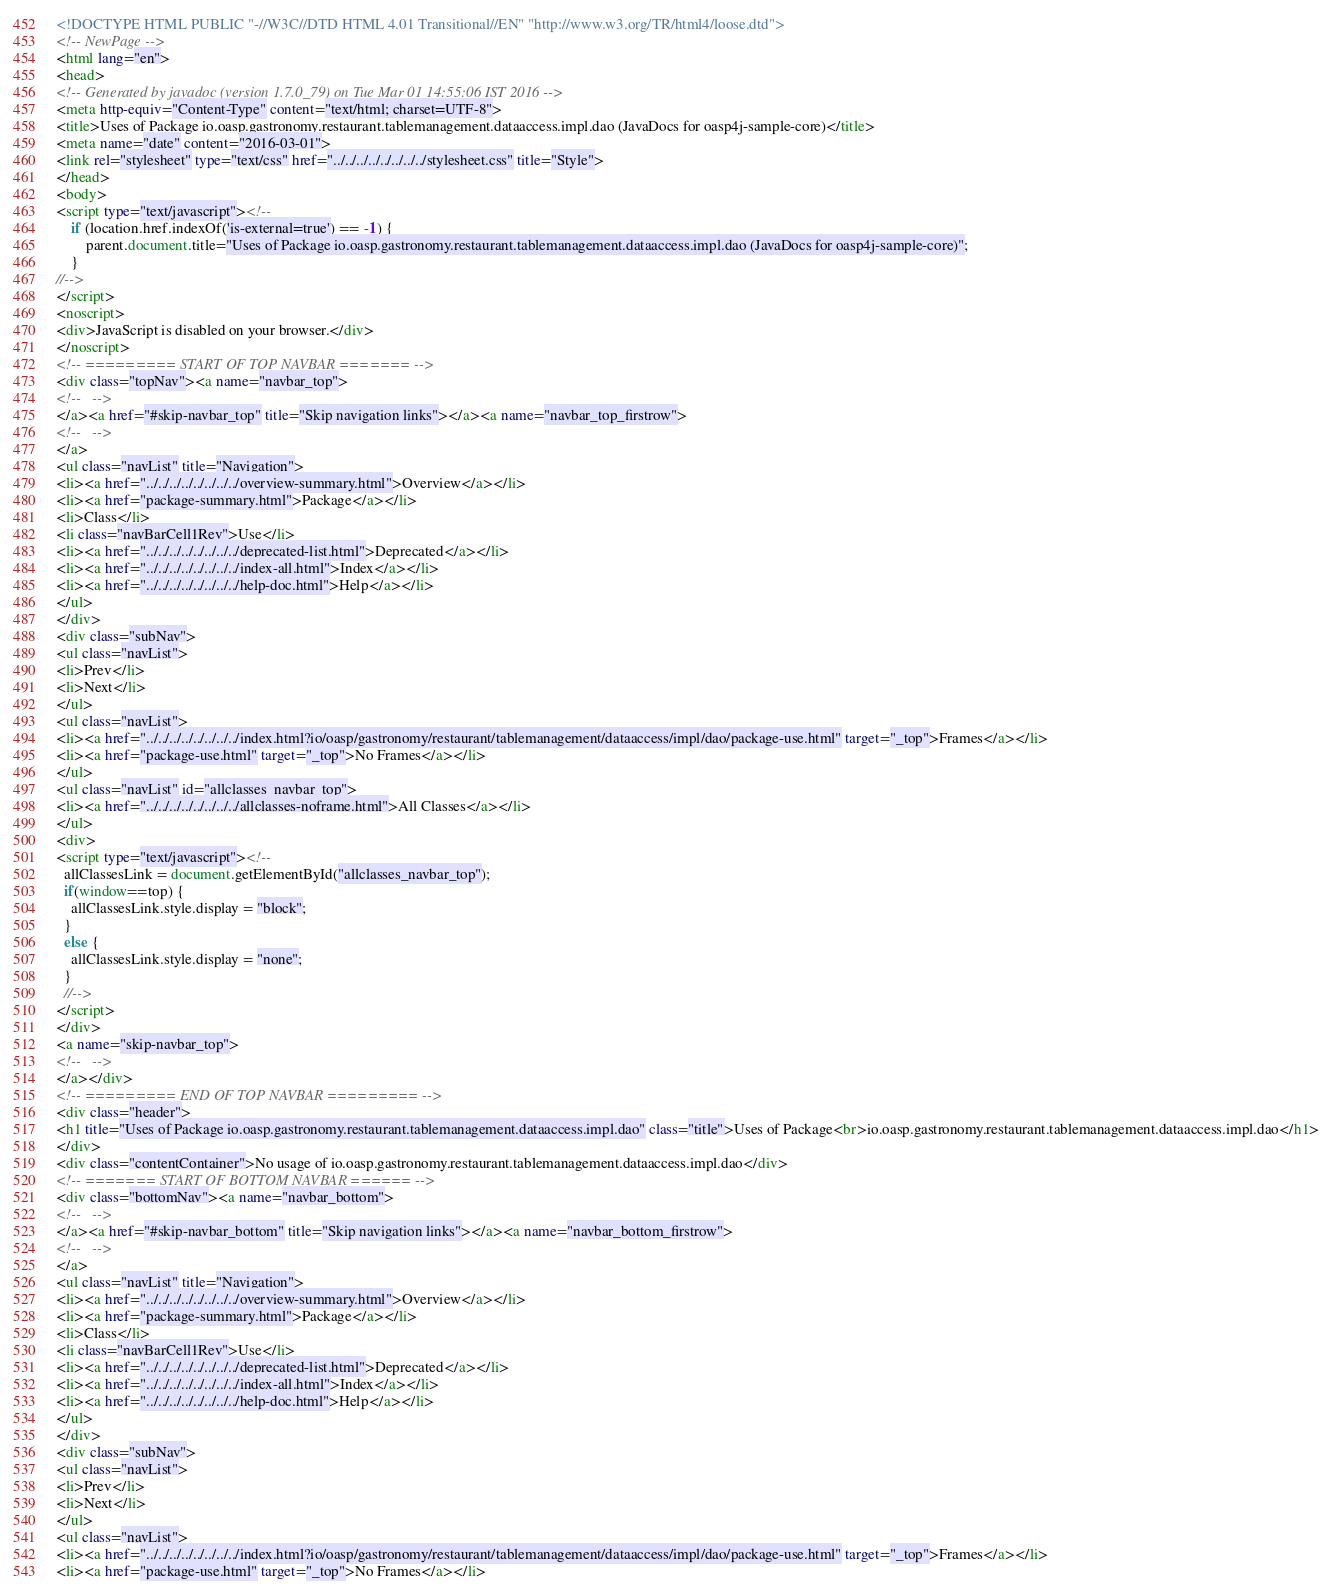Convert code to text. <code><loc_0><loc_0><loc_500><loc_500><_HTML_><!DOCTYPE HTML PUBLIC "-//W3C//DTD HTML 4.01 Transitional//EN" "http://www.w3.org/TR/html4/loose.dtd">
<!-- NewPage -->
<html lang="en">
<head>
<!-- Generated by javadoc (version 1.7.0_79) on Tue Mar 01 14:55:06 IST 2016 -->
<meta http-equiv="Content-Type" content="text/html; charset=UTF-8">
<title>Uses of Package io.oasp.gastronomy.restaurant.tablemanagement.dataaccess.impl.dao (JavaDocs for oasp4j-sample-core)</title>
<meta name="date" content="2016-03-01">
<link rel="stylesheet" type="text/css" href="../../../../../../../../stylesheet.css" title="Style">
</head>
<body>
<script type="text/javascript"><!--
    if (location.href.indexOf('is-external=true') == -1) {
        parent.document.title="Uses of Package io.oasp.gastronomy.restaurant.tablemanagement.dataaccess.impl.dao (JavaDocs for oasp4j-sample-core)";
    }
//-->
</script>
<noscript>
<div>JavaScript is disabled on your browser.</div>
</noscript>
<!-- ========= START OF TOP NAVBAR ======= -->
<div class="topNav"><a name="navbar_top">
<!--   -->
</a><a href="#skip-navbar_top" title="Skip navigation links"></a><a name="navbar_top_firstrow">
<!--   -->
</a>
<ul class="navList" title="Navigation">
<li><a href="../../../../../../../../overview-summary.html">Overview</a></li>
<li><a href="package-summary.html">Package</a></li>
<li>Class</li>
<li class="navBarCell1Rev">Use</li>
<li><a href="../../../../../../../../deprecated-list.html">Deprecated</a></li>
<li><a href="../../../../../../../../index-all.html">Index</a></li>
<li><a href="../../../../../../../../help-doc.html">Help</a></li>
</ul>
</div>
<div class="subNav">
<ul class="navList">
<li>Prev</li>
<li>Next</li>
</ul>
<ul class="navList">
<li><a href="../../../../../../../../index.html?io/oasp/gastronomy/restaurant/tablemanagement/dataaccess/impl/dao/package-use.html" target="_top">Frames</a></li>
<li><a href="package-use.html" target="_top">No Frames</a></li>
</ul>
<ul class="navList" id="allclasses_navbar_top">
<li><a href="../../../../../../../../allclasses-noframe.html">All Classes</a></li>
</ul>
<div>
<script type="text/javascript"><!--
  allClassesLink = document.getElementById("allclasses_navbar_top");
  if(window==top) {
    allClassesLink.style.display = "block";
  }
  else {
    allClassesLink.style.display = "none";
  }
  //-->
</script>
</div>
<a name="skip-navbar_top">
<!--   -->
</a></div>
<!-- ========= END OF TOP NAVBAR ========= -->
<div class="header">
<h1 title="Uses of Package io.oasp.gastronomy.restaurant.tablemanagement.dataaccess.impl.dao" class="title">Uses of Package<br>io.oasp.gastronomy.restaurant.tablemanagement.dataaccess.impl.dao</h1>
</div>
<div class="contentContainer">No usage of io.oasp.gastronomy.restaurant.tablemanagement.dataaccess.impl.dao</div>
<!-- ======= START OF BOTTOM NAVBAR ====== -->
<div class="bottomNav"><a name="navbar_bottom">
<!--   -->
</a><a href="#skip-navbar_bottom" title="Skip navigation links"></a><a name="navbar_bottom_firstrow">
<!--   -->
</a>
<ul class="navList" title="Navigation">
<li><a href="../../../../../../../../overview-summary.html">Overview</a></li>
<li><a href="package-summary.html">Package</a></li>
<li>Class</li>
<li class="navBarCell1Rev">Use</li>
<li><a href="../../../../../../../../deprecated-list.html">Deprecated</a></li>
<li><a href="../../../../../../../../index-all.html">Index</a></li>
<li><a href="../../../../../../../../help-doc.html">Help</a></li>
</ul>
</div>
<div class="subNav">
<ul class="navList">
<li>Prev</li>
<li>Next</li>
</ul>
<ul class="navList">
<li><a href="../../../../../../../../index.html?io/oasp/gastronomy/restaurant/tablemanagement/dataaccess/impl/dao/package-use.html" target="_top">Frames</a></li>
<li><a href="package-use.html" target="_top">No Frames</a></li></code> 